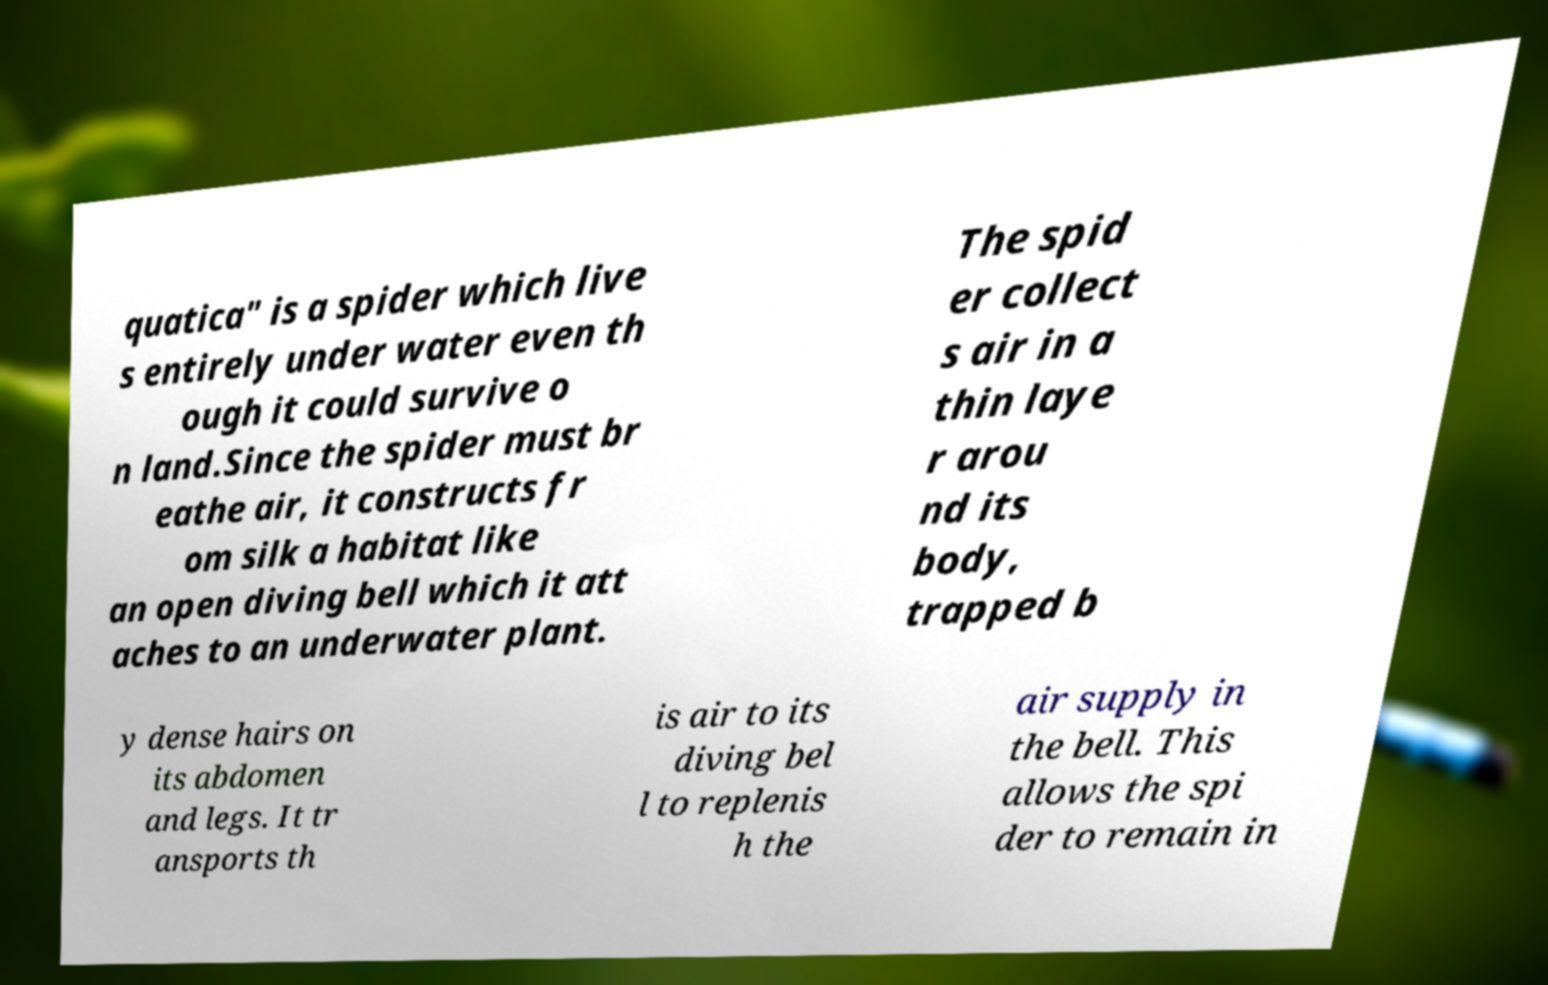What messages or text are displayed in this image? I need them in a readable, typed format. quatica" is a spider which live s entirely under water even th ough it could survive o n land.Since the spider must br eathe air, it constructs fr om silk a habitat like an open diving bell which it att aches to an underwater plant. The spid er collect s air in a thin laye r arou nd its body, trapped b y dense hairs on its abdomen and legs. It tr ansports th is air to its diving bel l to replenis h the air supply in the bell. This allows the spi der to remain in 